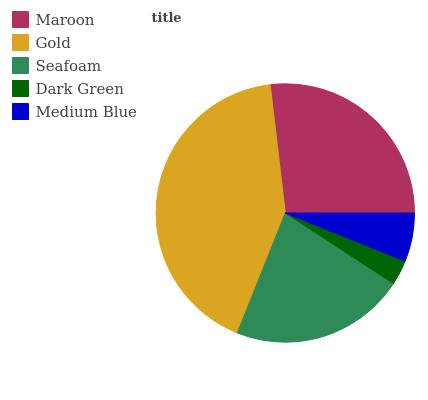Is Dark Green the minimum?
Answer yes or no. Yes. Is Gold the maximum?
Answer yes or no. Yes. Is Seafoam the minimum?
Answer yes or no. No. Is Seafoam the maximum?
Answer yes or no. No. Is Gold greater than Seafoam?
Answer yes or no. Yes. Is Seafoam less than Gold?
Answer yes or no. Yes. Is Seafoam greater than Gold?
Answer yes or no. No. Is Gold less than Seafoam?
Answer yes or no. No. Is Seafoam the high median?
Answer yes or no. Yes. Is Seafoam the low median?
Answer yes or no. Yes. Is Dark Green the high median?
Answer yes or no. No. Is Medium Blue the low median?
Answer yes or no. No. 